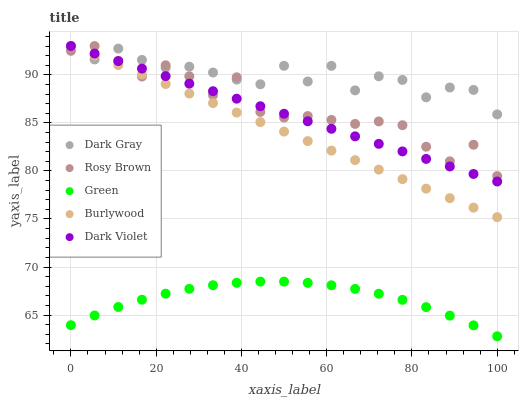Does Green have the minimum area under the curve?
Answer yes or no. Yes. Does Dark Gray have the maximum area under the curve?
Answer yes or no. Yes. Does Burlywood have the minimum area under the curve?
Answer yes or no. No. Does Burlywood have the maximum area under the curve?
Answer yes or no. No. Is Burlywood the smoothest?
Answer yes or no. Yes. Is Dark Gray the roughest?
Answer yes or no. Yes. Is Rosy Brown the smoothest?
Answer yes or no. No. Is Rosy Brown the roughest?
Answer yes or no. No. Does Green have the lowest value?
Answer yes or no. Yes. Does Burlywood have the lowest value?
Answer yes or no. No. Does Dark Violet have the highest value?
Answer yes or no. Yes. Does Rosy Brown have the highest value?
Answer yes or no. No. Is Green less than Dark Gray?
Answer yes or no. Yes. Is Rosy Brown greater than Green?
Answer yes or no. Yes. Does Rosy Brown intersect Dark Gray?
Answer yes or no. Yes. Is Rosy Brown less than Dark Gray?
Answer yes or no. No. Is Rosy Brown greater than Dark Gray?
Answer yes or no. No. Does Green intersect Dark Gray?
Answer yes or no. No. 